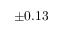Convert formula to latex. <formula><loc_0><loc_0><loc_500><loc_500>\pm 0 . 1 3</formula> 